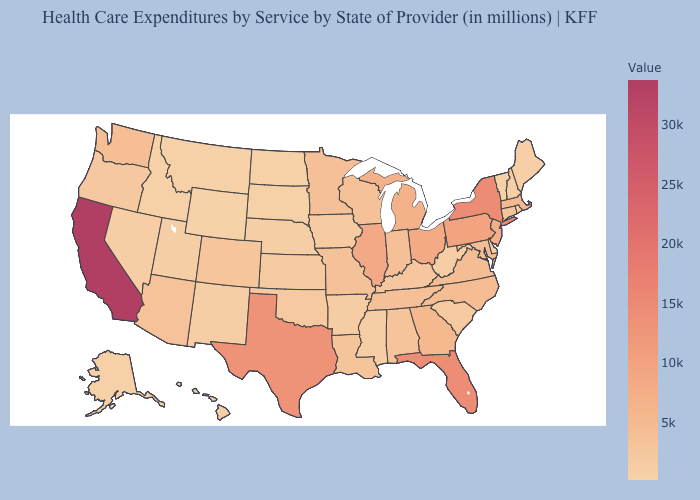Is the legend a continuous bar?
Answer briefly. Yes. Among the states that border Iowa , does South Dakota have the lowest value?
Quick response, please. Yes. Is the legend a continuous bar?
Write a very short answer. Yes. Among the states that border North Carolina , does Georgia have the highest value?
Be succinct. Yes. Does California have the highest value in the USA?
Be succinct. Yes. Among the states that border Connecticut , which have the lowest value?
Give a very brief answer. Rhode Island. Does California have the highest value in the West?
Quick response, please. Yes. 